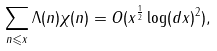Convert formula to latex. <formula><loc_0><loc_0><loc_500><loc_500>\sum _ { n \leqslant x } \Lambda ( n ) \chi ( n ) = O ( x ^ { \frac { 1 } { 2 } } \log ( d x ) ^ { 2 } ) ,</formula> 